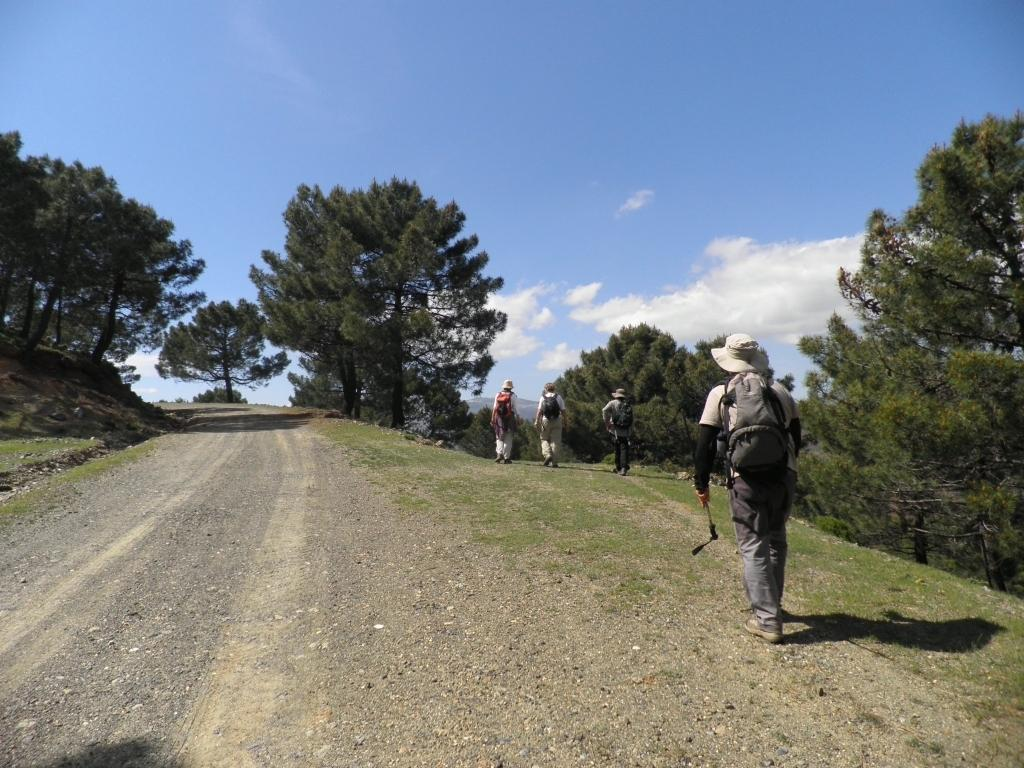How many people are in the image? There are people in the image, but the exact number is not specified. What are the people carrying in the image? The people are carrying bags in the image. What surface are the people walking on in the image? The people are walking on the ground in the image. What type of vegetation can be seen in the image? Trees are visible in the image. What is visible in the background of the image? The sky is visible in the background of the image. What can be observed in the sky in the image? Clouds are present in the sky in the image. What type of wilderness can be seen in the image? There is no wilderness present in the image; it features people walking on the ground with trees and clouds visible in the background. 